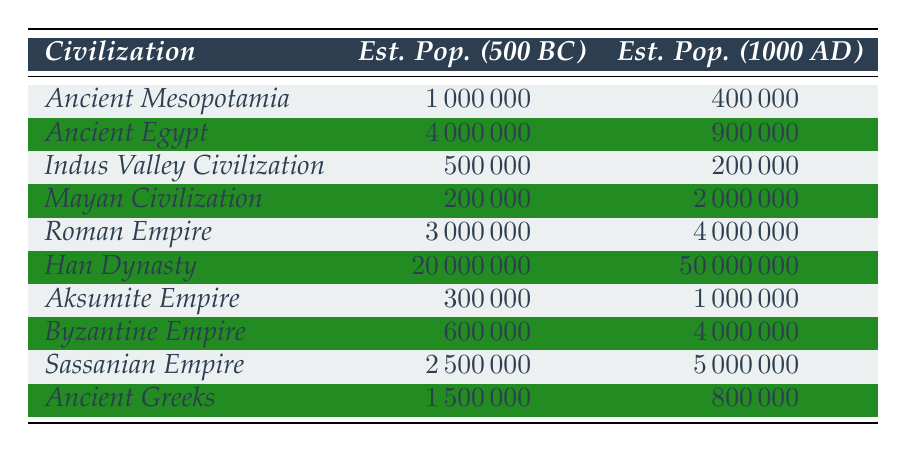What was the estimated population of the Han Dynasty in 500 BC? The table directly lists the estimated population of the Han Dynasty in 500 BC as 20,000,000.
Answer: 20,000,000 Which civilization had the highest estimated population in 1000 AD? By looking at the table, the Han Dynasty has the highest estimated population in 1000 AD, which is 50,000,000.
Answer: Han Dynasty How much did the population of Ancient Egypt decrease from 500 BC to 1000 AD? The estimated population of Ancient Egypt in 500 BC is 4,000,000 and in 1000 AD it is 900,000. The decrease is calculated as 4,000,000 - 900,000 = 3,100,000.
Answer: 3,100,000 What is the estimated population difference between the Roman Empire and the Byzantine Empire in 500 BC? The estimated population of the Roman Empire in 500 BC is 3,000,000 and that of the Byzantine Empire is 600,000. The difference is 3,000,000 - 600,000 = 2,400,000.
Answer: 2,400,000 Did the population of the Mayan Civilization increase or decrease from 500 BC to 1000 AD? The estimated population of the Mayan Civilization remained the same in 500 BC (200,000) and in 1000 AD (2,000,000), indicating an increase.
Answer: Yes Which civilization had the estimated population of 500,000 in 500 BC? The Indus Valley Civilization has the estimated population of 500,000 in 500 BC as stated in the table.
Answer: Indus Valley Civilization What is the average population of all civilizations in 1000 AD? To find the average, sum the populations of all civilizations in 1000 AD: (400,000 + 900,000 + 200,000 + 2,000,000 + 4,000,000 + 50,000,000 + 1,000,000 + 4,000,000 + 5,000,000 + 800,000) = 68,400,000; then divide by the number of civilizations (10): 68,400,000 / 10 = 6,840,000.
Answer: 6,840,000 Where do the Aksumite Empire and Sassanian Empire compare in terms of population estimates in 1000 AD? The Aksumite Empire has an estimated population of 1,000,000 and the Sassanian Empire has 5,000,000 in 1000 AD, showing that the Sassanian Empire has a significantly higher population.
Answer: Sassanian Empire has a higher population What percentage of the population did the Ancient Greeks represent in 500 BC compared to the Han Dynasty? The estimated population of Ancient Greeks in 500 BC is 1,500,000 and for Han Dynasty is 20,000,000. The percentage is calculated as (1,500,000 / 20,000,000) * 100 = 7.5%.
Answer: 7.5% Which civilization saw the largest growth in estimated population between 500 BC and 1000 AD? By comparing the differences for each civilization, the Han Dynasty had an increase from 20,000,000 to 50,000,000, a growth of 30,000,000. No other civilization had such a substantial increase.
Answer: Han Dynasty with 30,000,000 increase 